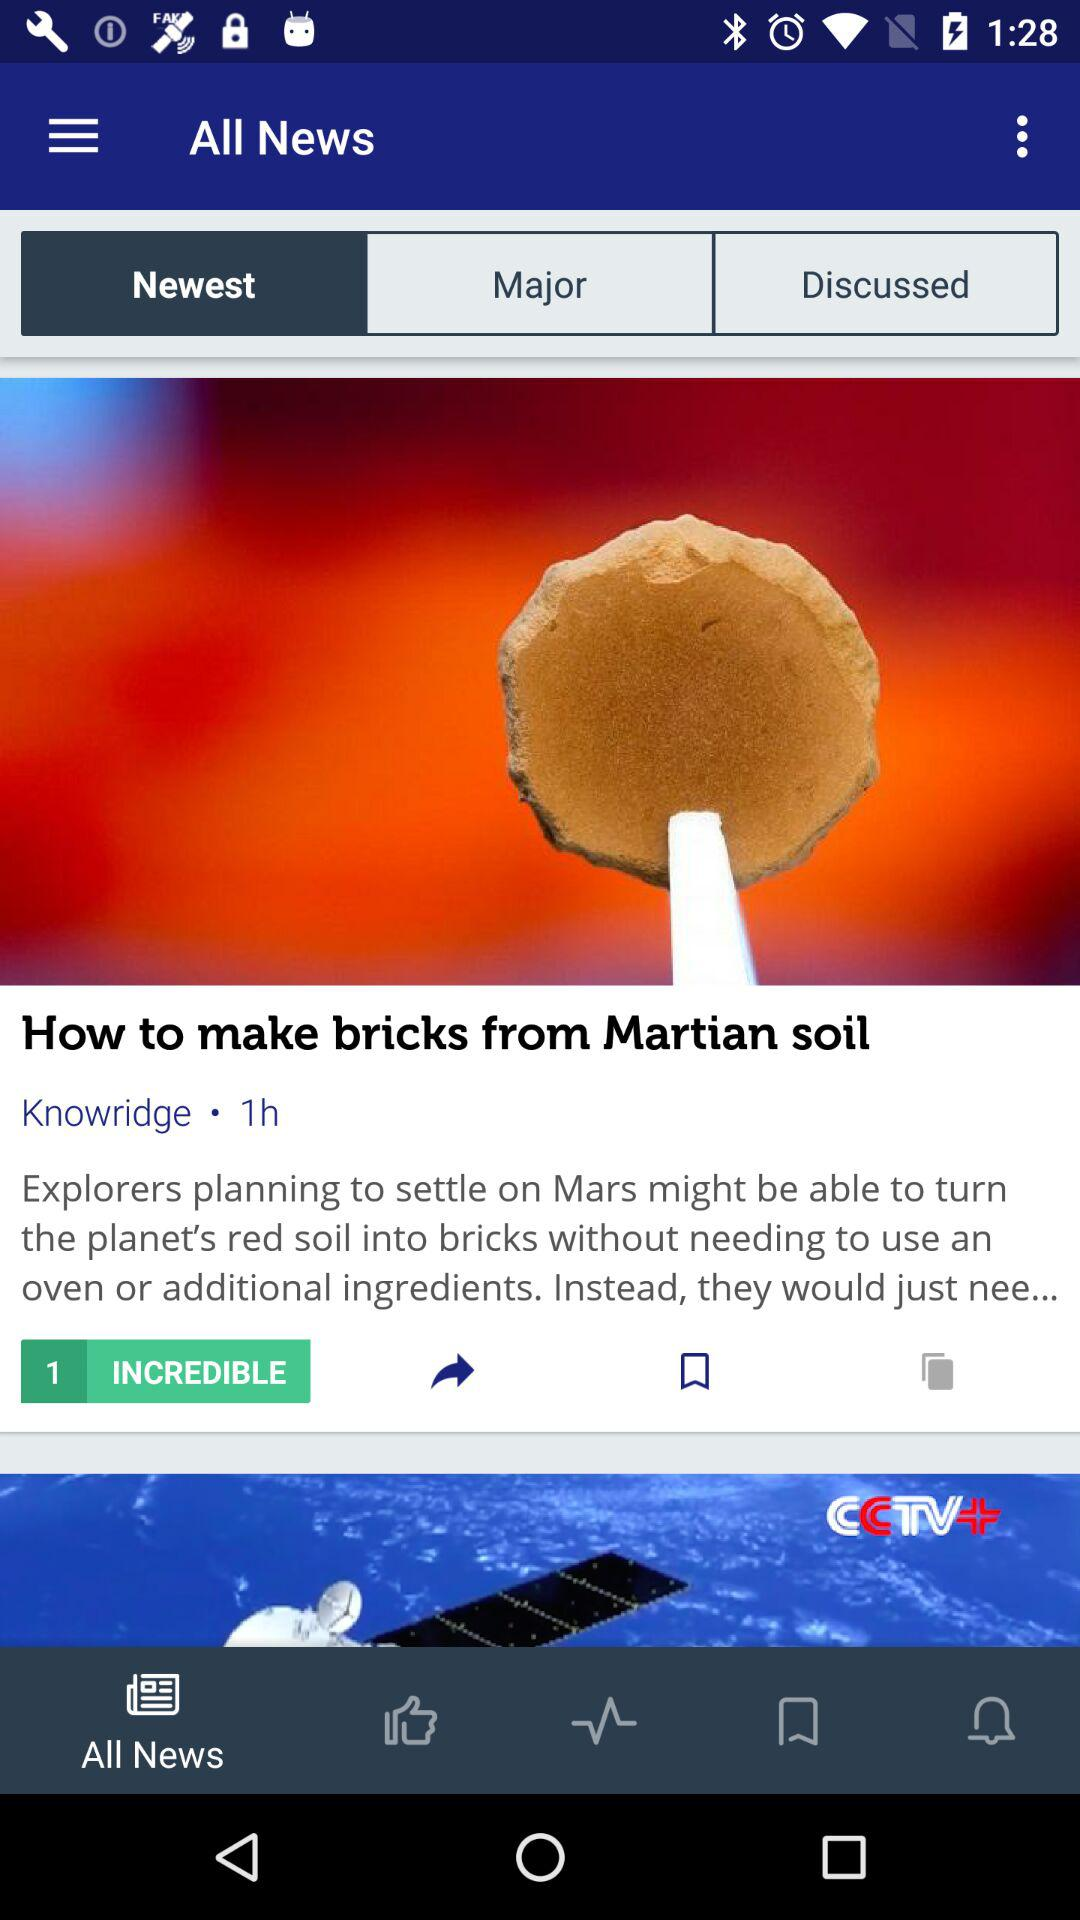When was the news "How to make bricks from Martian soil" posted? The news "How to make bricks from Martian soil" was posted 1 hour ago. 